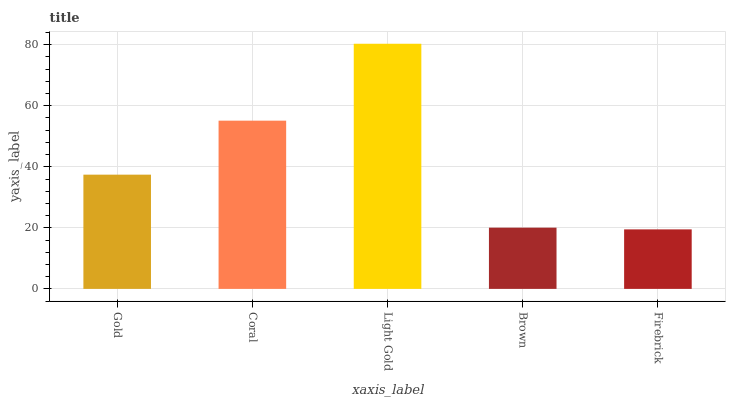Is Coral the minimum?
Answer yes or no. No. Is Coral the maximum?
Answer yes or no. No. Is Coral greater than Gold?
Answer yes or no. Yes. Is Gold less than Coral?
Answer yes or no. Yes. Is Gold greater than Coral?
Answer yes or no. No. Is Coral less than Gold?
Answer yes or no. No. Is Gold the high median?
Answer yes or no. Yes. Is Gold the low median?
Answer yes or no. Yes. Is Brown the high median?
Answer yes or no. No. Is Coral the low median?
Answer yes or no. No. 